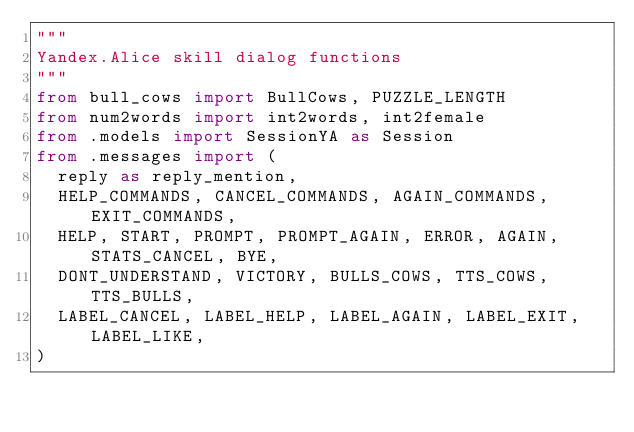<code> <loc_0><loc_0><loc_500><loc_500><_Python_>"""
Yandex.Alice skill dialog functions
"""
from bull_cows import BullCows, PUZZLE_LENGTH
from num2words import int2words, int2female
from .models import SessionYA as Session
from .messages import (
  reply as reply_mention,
  HELP_COMMANDS, CANCEL_COMMANDS, AGAIN_COMMANDS, EXIT_COMMANDS,
  HELP, START, PROMPT, PROMPT_AGAIN, ERROR, AGAIN, STATS_CANCEL, BYE,
  DONT_UNDERSTAND, VICTORY, BULLS_COWS, TTS_COWS, TTS_BULLS,
  LABEL_CANCEL, LABEL_HELP, LABEL_AGAIN, LABEL_EXIT, LABEL_LIKE,
)
</code> 